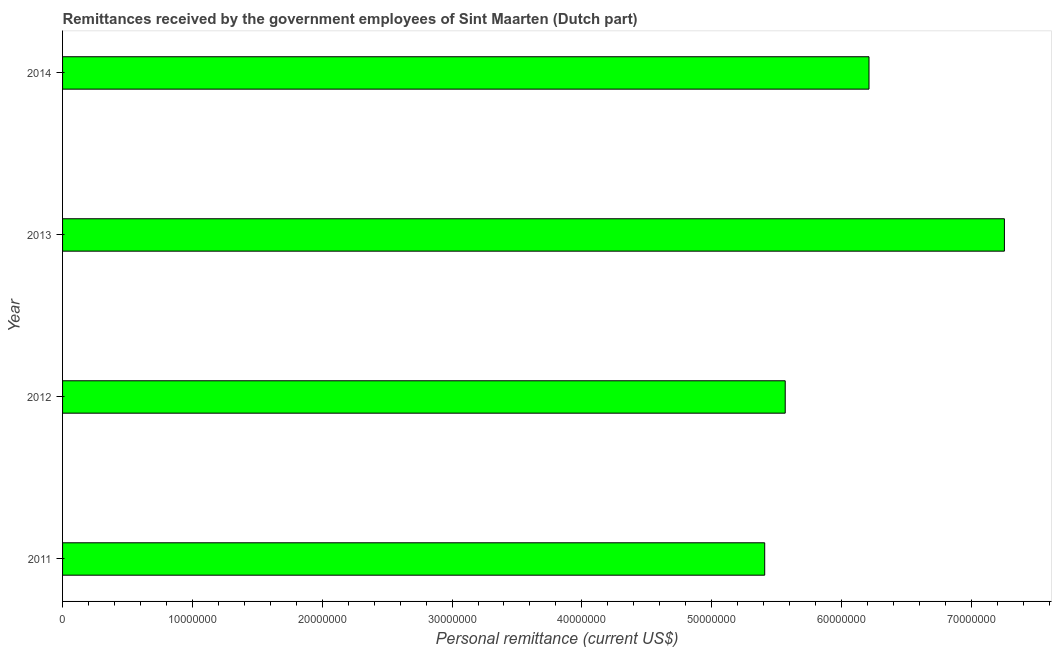Does the graph contain grids?
Provide a succinct answer. No. What is the title of the graph?
Your response must be concise. Remittances received by the government employees of Sint Maarten (Dutch part). What is the label or title of the X-axis?
Offer a terse response. Personal remittance (current US$). What is the label or title of the Y-axis?
Provide a short and direct response. Year. What is the personal remittances in 2011?
Your answer should be very brief. 5.41e+07. Across all years, what is the maximum personal remittances?
Your answer should be compact. 7.25e+07. Across all years, what is the minimum personal remittances?
Make the answer very short. 5.41e+07. In which year was the personal remittances minimum?
Ensure brevity in your answer.  2011. What is the sum of the personal remittances?
Offer a terse response. 2.44e+08. What is the difference between the personal remittances in 2013 and 2014?
Make the answer very short. 1.04e+07. What is the average personal remittances per year?
Your answer should be compact. 6.11e+07. What is the median personal remittances?
Your response must be concise. 5.89e+07. What is the ratio of the personal remittances in 2012 to that in 2014?
Keep it short and to the point. 0.9. Is the difference between the personal remittances in 2013 and 2014 greater than the difference between any two years?
Ensure brevity in your answer.  No. What is the difference between the highest and the second highest personal remittances?
Give a very brief answer. 1.04e+07. Is the sum of the personal remittances in 2013 and 2014 greater than the maximum personal remittances across all years?
Give a very brief answer. Yes. What is the difference between the highest and the lowest personal remittances?
Offer a terse response. 1.85e+07. Are all the bars in the graph horizontal?
Offer a terse response. Yes. What is the Personal remittance (current US$) in 2011?
Offer a very short reply. 5.41e+07. What is the Personal remittance (current US$) in 2012?
Provide a succinct answer. 5.57e+07. What is the Personal remittance (current US$) in 2013?
Offer a terse response. 7.25e+07. What is the Personal remittance (current US$) of 2014?
Offer a terse response. 6.21e+07. What is the difference between the Personal remittance (current US$) in 2011 and 2012?
Your answer should be very brief. -1.58e+06. What is the difference between the Personal remittance (current US$) in 2011 and 2013?
Provide a short and direct response. -1.85e+07. What is the difference between the Personal remittance (current US$) in 2011 and 2014?
Provide a succinct answer. -8.03e+06. What is the difference between the Personal remittance (current US$) in 2012 and 2013?
Your answer should be very brief. -1.69e+07. What is the difference between the Personal remittance (current US$) in 2012 and 2014?
Your answer should be very brief. -6.45e+06. What is the difference between the Personal remittance (current US$) in 2013 and 2014?
Keep it short and to the point. 1.04e+07. What is the ratio of the Personal remittance (current US$) in 2011 to that in 2013?
Your response must be concise. 0.74. What is the ratio of the Personal remittance (current US$) in 2011 to that in 2014?
Your answer should be compact. 0.87. What is the ratio of the Personal remittance (current US$) in 2012 to that in 2013?
Keep it short and to the point. 0.77. What is the ratio of the Personal remittance (current US$) in 2012 to that in 2014?
Ensure brevity in your answer.  0.9. What is the ratio of the Personal remittance (current US$) in 2013 to that in 2014?
Your answer should be very brief. 1.17. 